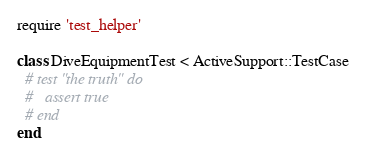Convert code to text. <code><loc_0><loc_0><loc_500><loc_500><_Ruby_>require 'test_helper'

class DiveEquipmentTest < ActiveSupport::TestCase
  # test "the truth" do
  #   assert true
  # end
end
</code> 